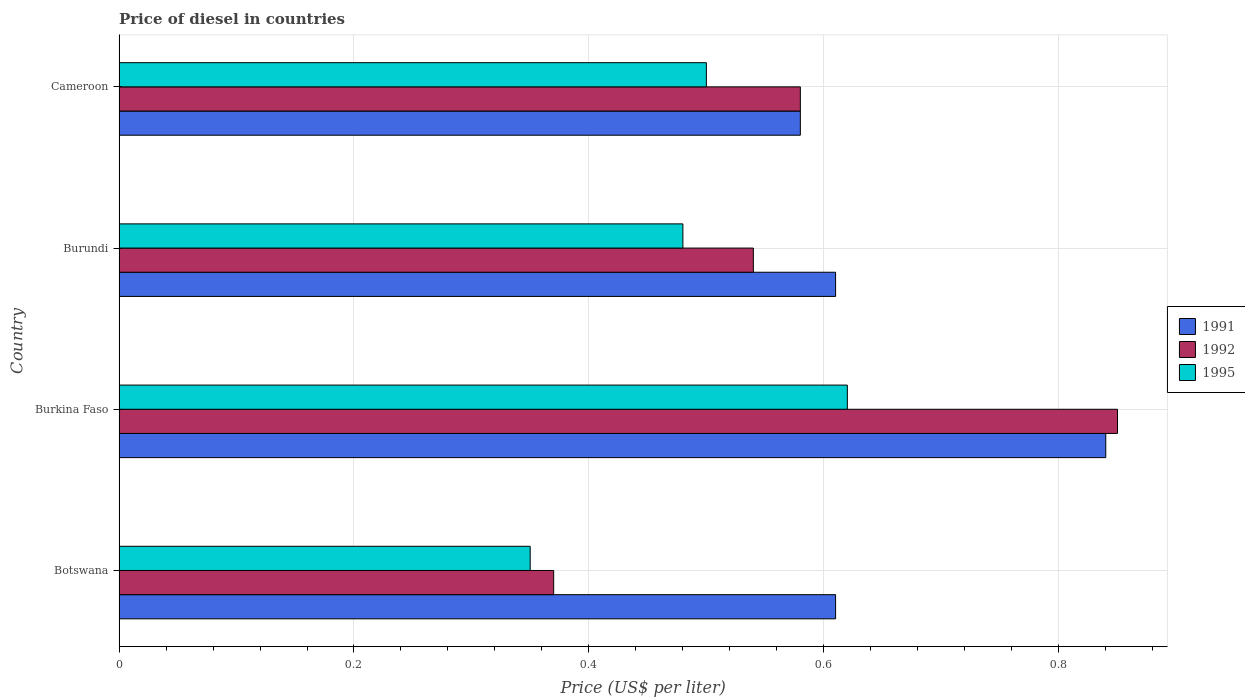How many different coloured bars are there?
Keep it short and to the point. 3. How many groups of bars are there?
Provide a short and direct response. 4. Are the number of bars on each tick of the Y-axis equal?
Offer a terse response. Yes. How many bars are there on the 3rd tick from the bottom?
Keep it short and to the point. 3. What is the label of the 1st group of bars from the top?
Your answer should be compact. Cameroon. In how many cases, is the number of bars for a given country not equal to the number of legend labels?
Offer a very short reply. 0. What is the price of diesel in 1992 in Burundi?
Keep it short and to the point. 0.54. Across all countries, what is the maximum price of diesel in 1995?
Offer a terse response. 0.62. Across all countries, what is the minimum price of diesel in 1992?
Your response must be concise. 0.37. In which country was the price of diesel in 1995 maximum?
Provide a short and direct response. Burkina Faso. In which country was the price of diesel in 1992 minimum?
Give a very brief answer. Botswana. What is the total price of diesel in 1992 in the graph?
Offer a terse response. 2.34. What is the difference between the price of diesel in 1995 in Burkina Faso and that in Burundi?
Offer a terse response. 0.14. What is the difference between the price of diesel in 1991 in Cameroon and the price of diesel in 1995 in Botswana?
Your answer should be compact. 0.23. What is the average price of diesel in 1995 per country?
Provide a short and direct response. 0.49. What is the difference between the price of diesel in 1991 and price of diesel in 1995 in Cameroon?
Provide a succinct answer. 0.08. What is the ratio of the price of diesel in 1992 in Burkina Faso to that in Cameroon?
Provide a short and direct response. 1.47. Is the difference between the price of diesel in 1991 in Botswana and Burkina Faso greater than the difference between the price of diesel in 1995 in Botswana and Burkina Faso?
Keep it short and to the point. Yes. What is the difference between the highest and the second highest price of diesel in 1995?
Offer a terse response. 0.12. What is the difference between the highest and the lowest price of diesel in 1995?
Ensure brevity in your answer.  0.27. How many bars are there?
Give a very brief answer. 12. Are all the bars in the graph horizontal?
Your response must be concise. Yes. How many countries are there in the graph?
Provide a short and direct response. 4. Are the values on the major ticks of X-axis written in scientific E-notation?
Your response must be concise. No. Does the graph contain any zero values?
Offer a very short reply. No. What is the title of the graph?
Offer a terse response. Price of diesel in countries. What is the label or title of the X-axis?
Make the answer very short. Price (US$ per liter). What is the label or title of the Y-axis?
Offer a very short reply. Country. What is the Price (US$ per liter) in 1991 in Botswana?
Make the answer very short. 0.61. What is the Price (US$ per liter) in 1992 in Botswana?
Ensure brevity in your answer.  0.37. What is the Price (US$ per liter) of 1995 in Botswana?
Your response must be concise. 0.35. What is the Price (US$ per liter) of 1991 in Burkina Faso?
Ensure brevity in your answer.  0.84. What is the Price (US$ per liter) of 1995 in Burkina Faso?
Your answer should be very brief. 0.62. What is the Price (US$ per liter) in 1991 in Burundi?
Your answer should be very brief. 0.61. What is the Price (US$ per liter) in 1992 in Burundi?
Keep it short and to the point. 0.54. What is the Price (US$ per liter) of 1995 in Burundi?
Offer a terse response. 0.48. What is the Price (US$ per liter) in 1991 in Cameroon?
Your response must be concise. 0.58. What is the Price (US$ per liter) in 1992 in Cameroon?
Provide a short and direct response. 0.58. What is the Price (US$ per liter) in 1995 in Cameroon?
Your response must be concise. 0.5. Across all countries, what is the maximum Price (US$ per liter) of 1991?
Provide a short and direct response. 0.84. Across all countries, what is the maximum Price (US$ per liter) of 1995?
Keep it short and to the point. 0.62. Across all countries, what is the minimum Price (US$ per liter) of 1991?
Your answer should be very brief. 0.58. Across all countries, what is the minimum Price (US$ per liter) in 1992?
Make the answer very short. 0.37. What is the total Price (US$ per liter) in 1991 in the graph?
Your response must be concise. 2.64. What is the total Price (US$ per liter) of 1992 in the graph?
Offer a very short reply. 2.34. What is the total Price (US$ per liter) of 1995 in the graph?
Make the answer very short. 1.95. What is the difference between the Price (US$ per liter) in 1991 in Botswana and that in Burkina Faso?
Your response must be concise. -0.23. What is the difference between the Price (US$ per liter) of 1992 in Botswana and that in Burkina Faso?
Provide a short and direct response. -0.48. What is the difference between the Price (US$ per liter) in 1995 in Botswana and that in Burkina Faso?
Give a very brief answer. -0.27. What is the difference between the Price (US$ per liter) of 1991 in Botswana and that in Burundi?
Provide a short and direct response. 0. What is the difference between the Price (US$ per liter) in 1992 in Botswana and that in Burundi?
Give a very brief answer. -0.17. What is the difference between the Price (US$ per liter) in 1995 in Botswana and that in Burundi?
Ensure brevity in your answer.  -0.13. What is the difference between the Price (US$ per liter) in 1992 in Botswana and that in Cameroon?
Provide a short and direct response. -0.21. What is the difference between the Price (US$ per liter) of 1995 in Botswana and that in Cameroon?
Provide a succinct answer. -0.15. What is the difference between the Price (US$ per liter) in 1991 in Burkina Faso and that in Burundi?
Provide a short and direct response. 0.23. What is the difference between the Price (US$ per liter) of 1992 in Burkina Faso and that in Burundi?
Your response must be concise. 0.31. What is the difference between the Price (US$ per liter) of 1995 in Burkina Faso and that in Burundi?
Give a very brief answer. 0.14. What is the difference between the Price (US$ per liter) of 1991 in Burkina Faso and that in Cameroon?
Ensure brevity in your answer.  0.26. What is the difference between the Price (US$ per liter) in 1992 in Burkina Faso and that in Cameroon?
Your answer should be compact. 0.27. What is the difference between the Price (US$ per liter) of 1995 in Burkina Faso and that in Cameroon?
Make the answer very short. 0.12. What is the difference between the Price (US$ per liter) in 1992 in Burundi and that in Cameroon?
Ensure brevity in your answer.  -0.04. What is the difference between the Price (US$ per liter) of 1995 in Burundi and that in Cameroon?
Offer a terse response. -0.02. What is the difference between the Price (US$ per liter) in 1991 in Botswana and the Price (US$ per liter) in 1992 in Burkina Faso?
Keep it short and to the point. -0.24. What is the difference between the Price (US$ per liter) of 1991 in Botswana and the Price (US$ per liter) of 1995 in Burkina Faso?
Your answer should be compact. -0.01. What is the difference between the Price (US$ per liter) in 1992 in Botswana and the Price (US$ per liter) in 1995 in Burkina Faso?
Your response must be concise. -0.25. What is the difference between the Price (US$ per liter) in 1991 in Botswana and the Price (US$ per liter) in 1992 in Burundi?
Your answer should be very brief. 0.07. What is the difference between the Price (US$ per liter) in 1991 in Botswana and the Price (US$ per liter) in 1995 in Burundi?
Provide a succinct answer. 0.13. What is the difference between the Price (US$ per liter) in 1992 in Botswana and the Price (US$ per liter) in 1995 in Burundi?
Make the answer very short. -0.11. What is the difference between the Price (US$ per liter) of 1991 in Botswana and the Price (US$ per liter) of 1992 in Cameroon?
Your answer should be compact. 0.03. What is the difference between the Price (US$ per liter) in 1991 in Botswana and the Price (US$ per liter) in 1995 in Cameroon?
Your answer should be very brief. 0.11. What is the difference between the Price (US$ per liter) in 1992 in Botswana and the Price (US$ per liter) in 1995 in Cameroon?
Keep it short and to the point. -0.13. What is the difference between the Price (US$ per liter) of 1991 in Burkina Faso and the Price (US$ per liter) of 1995 in Burundi?
Your response must be concise. 0.36. What is the difference between the Price (US$ per liter) of 1992 in Burkina Faso and the Price (US$ per liter) of 1995 in Burundi?
Make the answer very short. 0.37. What is the difference between the Price (US$ per liter) of 1991 in Burkina Faso and the Price (US$ per liter) of 1992 in Cameroon?
Give a very brief answer. 0.26. What is the difference between the Price (US$ per liter) of 1991 in Burkina Faso and the Price (US$ per liter) of 1995 in Cameroon?
Provide a succinct answer. 0.34. What is the difference between the Price (US$ per liter) of 1992 in Burkina Faso and the Price (US$ per liter) of 1995 in Cameroon?
Ensure brevity in your answer.  0.35. What is the difference between the Price (US$ per liter) of 1991 in Burundi and the Price (US$ per liter) of 1995 in Cameroon?
Make the answer very short. 0.11. What is the average Price (US$ per liter) of 1991 per country?
Ensure brevity in your answer.  0.66. What is the average Price (US$ per liter) in 1992 per country?
Offer a very short reply. 0.58. What is the average Price (US$ per liter) of 1995 per country?
Provide a short and direct response. 0.49. What is the difference between the Price (US$ per liter) of 1991 and Price (US$ per liter) of 1992 in Botswana?
Provide a short and direct response. 0.24. What is the difference between the Price (US$ per liter) in 1991 and Price (US$ per liter) in 1995 in Botswana?
Your response must be concise. 0.26. What is the difference between the Price (US$ per liter) in 1991 and Price (US$ per liter) in 1992 in Burkina Faso?
Your answer should be very brief. -0.01. What is the difference between the Price (US$ per liter) in 1991 and Price (US$ per liter) in 1995 in Burkina Faso?
Your answer should be very brief. 0.22. What is the difference between the Price (US$ per liter) of 1992 and Price (US$ per liter) of 1995 in Burkina Faso?
Give a very brief answer. 0.23. What is the difference between the Price (US$ per liter) in 1991 and Price (US$ per liter) in 1992 in Burundi?
Your answer should be very brief. 0.07. What is the difference between the Price (US$ per liter) in 1991 and Price (US$ per liter) in 1995 in Burundi?
Your response must be concise. 0.13. What is the difference between the Price (US$ per liter) of 1992 and Price (US$ per liter) of 1995 in Burundi?
Make the answer very short. 0.06. What is the difference between the Price (US$ per liter) in 1991 and Price (US$ per liter) in 1995 in Cameroon?
Your answer should be compact. 0.08. What is the difference between the Price (US$ per liter) in 1992 and Price (US$ per liter) in 1995 in Cameroon?
Offer a terse response. 0.08. What is the ratio of the Price (US$ per liter) of 1991 in Botswana to that in Burkina Faso?
Keep it short and to the point. 0.73. What is the ratio of the Price (US$ per liter) in 1992 in Botswana to that in Burkina Faso?
Provide a succinct answer. 0.44. What is the ratio of the Price (US$ per liter) of 1995 in Botswana to that in Burkina Faso?
Provide a short and direct response. 0.56. What is the ratio of the Price (US$ per liter) of 1991 in Botswana to that in Burundi?
Give a very brief answer. 1. What is the ratio of the Price (US$ per liter) in 1992 in Botswana to that in Burundi?
Provide a short and direct response. 0.69. What is the ratio of the Price (US$ per liter) in 1995 in Botswana to that in Burundi?
Ensure brevity in your answer.  0.73. What is the ratio of the Price (US$ per liter) in 1991 in Botswana to that in Cameroon?
Provide a succinct answer. 1.05. What is the ratio of the Price (US$ per liter) in 1992 in Botswana to that in Cameroon?
Provide a short and direct response. 0.64. What is the ratio of the Price (US$ per liter) of 1995 in Botswana to that in Cameroon?
Provide a succinct answer. 0.7. What is the ratio of the Price (US$ per liter) of 1991 in Burkina Faso to that in Burundi?
Provide a succinct answer. 1.38. What is the ratio of the Price (US$ per liter) of 1992 in Burkina Faso to that in Burundi?
Provide a short and direct response. 1.57. What is the ratio of the Price (US$ per liter) in 1995 in Burkina Faso to that in Burundi?
Offer a very short reply. 1.29. What is the ratio of the Price (US$ per liter) in 1991 in Burkina Faso to that in Cameroon?
Provide a succinct answer. 1.45. What is the ratio of the Price (US$ per liter) in 1992 in Burkina Faso to that in Cameroon?
Keep it short and to the point. 1.47. What is the ratio of the Price (US$ per liter) of 1995 in Burkina Faso to that in Cameroon?
Offer a terse response. 1.24. What is the ratio of the Price (US$ per liter) in 1991 in Burundi to that in Cameroon?
Your response must be concise. 1.05. What is the difference between the highest and the second highest Price (US$ per liter) of 1991?
Offer a very short reply. 0.23. What is the difference between the highest and the second highest Price (US$ per liter) in 1992?
Your answer should be very brief. 0.27. What is the difference between the highest and the second highest Price (US$ per liter) of 1995?
Your answer should be compact. 0.12. What is the difference between the highest and the lowest Price (US$ per liter) in 1991?
Give a very brief answer. 0.26. What is the difference between the highest and the lowest Price (US$ per liter) in 1992?
Provide a succinct answer. 0.48. What is the difference between the highest and the lowest Price (US$ per liter) of 1995?
Your answer should be very brief. 0.27. 